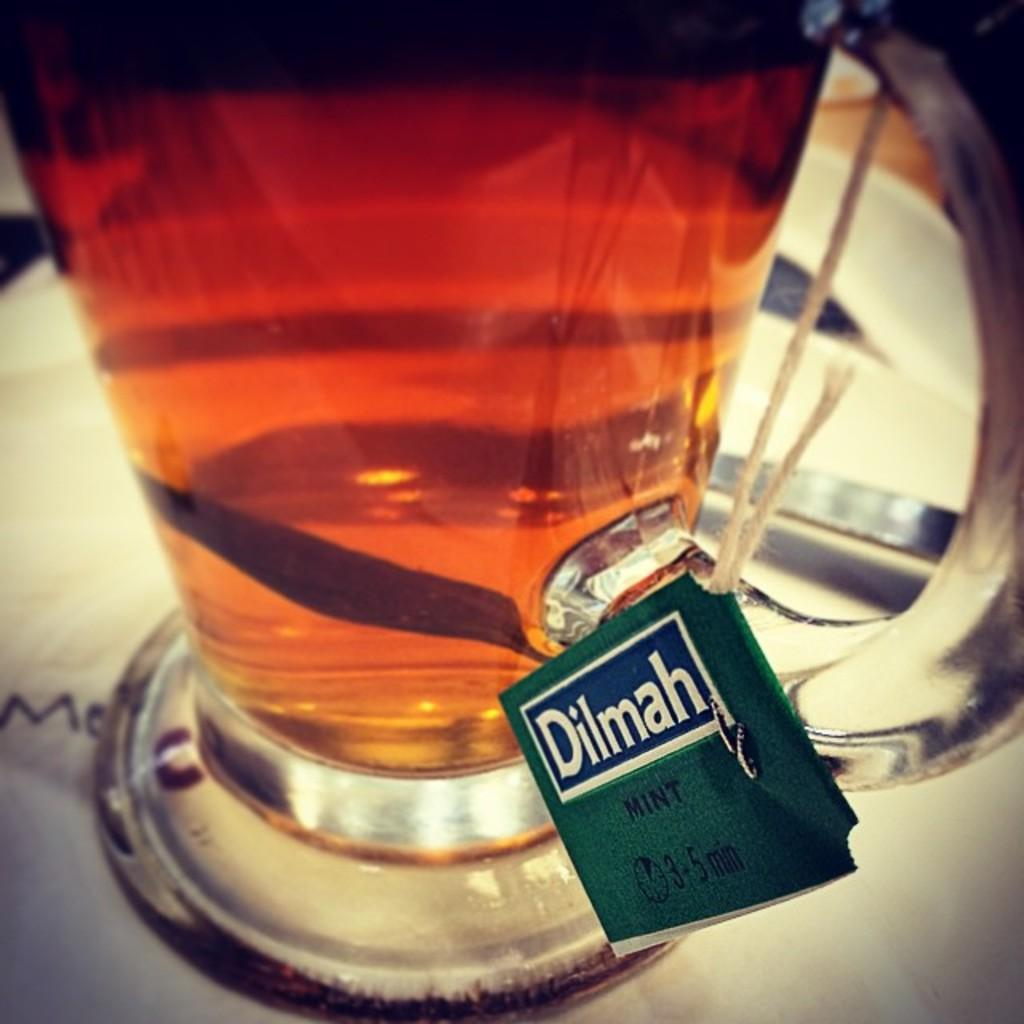<image>
Create a compact narrative representing the image presented. a big pitcher of amber liquid with a sign reading Dilmah Mint 